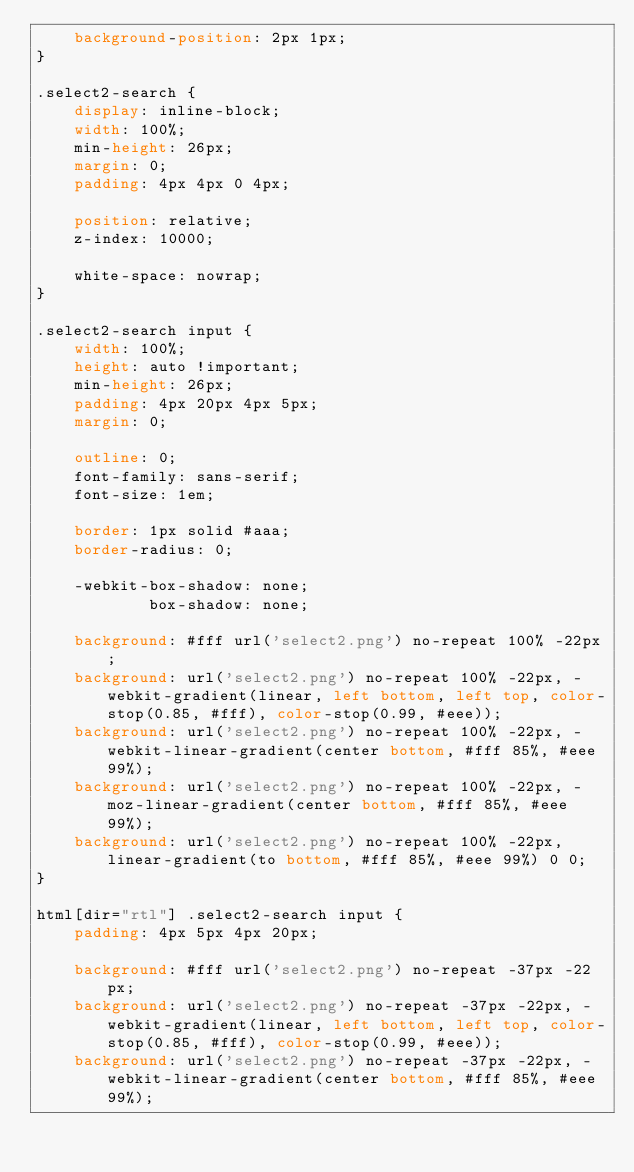<code> <loc_0><loc_0><loc_500><loc_500><_CSS_>    background-position: 2px 1px;
}

.select2-search {
    display: inline-block;
    width: 100%;
    min-height: 26px;
    margin: 0;
    padding: 4px 4px 0 4px;

    position: relative;
    z-index: 10000;

    white-space: nowrap;
}

.select2-search input {
    width: 100%;
    height: auto !important;
    min-height: 26px;
    padding: 4px 20px 4px 5px;
    margin: 0;

    outline: 0;
    font-family: sans-serif;
    font-size: 1em;

    border: 1px solid #aaa;
    border-radius: 0;

    -webkit-box-shadow: none;
            box-shadow: none;

    background: #fff url('select2.png') no-repeat 100% -22px;
    background: url('select2.png') no-repeat 100% -22px, -webkit-gradient(linear, left bottom, left top, color-stop(0.85, #fff), color-stop(0.99, #eee));
    background: url('select2.png') no-repeat 100% -22px, -webkit-linear-gradient(center bottom, #fff 85%, #eee 99%);
    background: url('select2.png') no-repeat 100% -22px, -moz-linear-gradient(center bottom, #fff 85%, #eee 99%);
    background: url('select2.png') no-repeat 100% -22px, linear-gradient(to bottom, #fff 85%, #eee 99%) 0 0;
}

html[dir="rtl"] .select2-search input {
    padding: 4px 5px 4px 20px;

    background: #fff url('select2.png') no-repeat -37px -22px;
    background: url('select2.png') no-repeat -37px -22px, -webkit-gradient(linear, left bottom, left top, color-stop(0.85, #fff), color-stop(0.99, #eee));
    background: url('select2.png') no-repeat -37px -22px, -webkit-linear-gradient(center bottom, #fff 85%, #eee 99%);</code> 